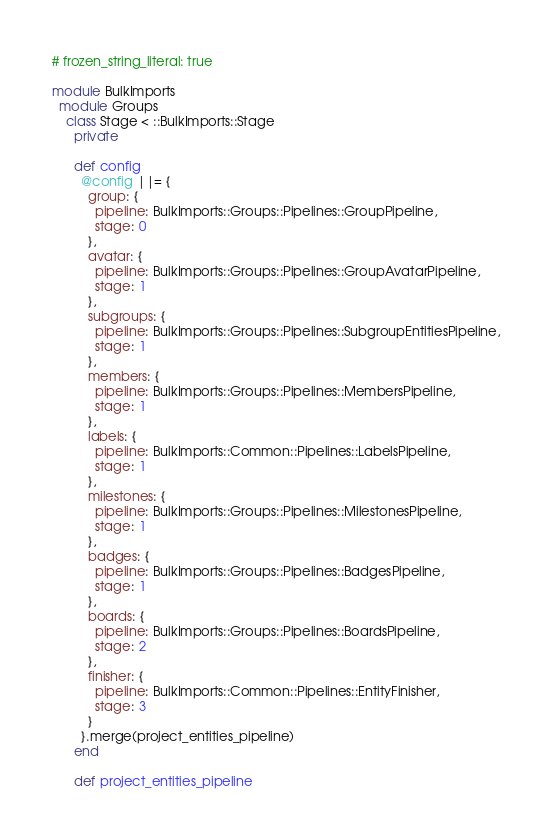Convert code to text. <code><loc_0><loc_0><loc_500><loc_500><_Ruby_># frozen_string_literal: true

module BulkImports
  module Groups
    class Stage < ::BulkImports::Stage
      private

      def config
        @config ||= {
          group: {
            pipeline: BulkImports::Groups::Pipelines::GroupPipeline,
            stage: 0
          },
          avatar: {
            pipeline: BulkImports::Groups::Pipelines::GroupAvatarPipeline,
            stage: 1
          },
          subgroups: {
            pipeline: BulkImports::Groups::Pipelines::SubgroupEntitiesPipeline,
            stage: 1
          },
          members: {
            pipeline: BulkImports::Groups::Pipelines::MembersPipeline,
            stage: 1
          },
          labels: {
            pipeline: BulkImports::Common::Pipelines::LabelsPipeline,
            stage: 1
          },
          milestones: {
            pipeline: BulkImports::Groups::Pipelines::MilestonesPipeline,
            stage: 1
          },
          badges: {
            pipeline: BulkImports::Groups::Pipelines::BadgesPipeline,
            stage: 1
          },
          boards: {
            pipeline: BulkImports::Groups::Pipelines::BoardsPipeline,
            stage: 2
          },
          finisher: {
            pipeline: BulkImports::Common::Pipelines::EntityFinisher,
            stage: 3
          }
        }.merge(project_entities_pipeline)
      end

      def project_entities_pipeline</code> 